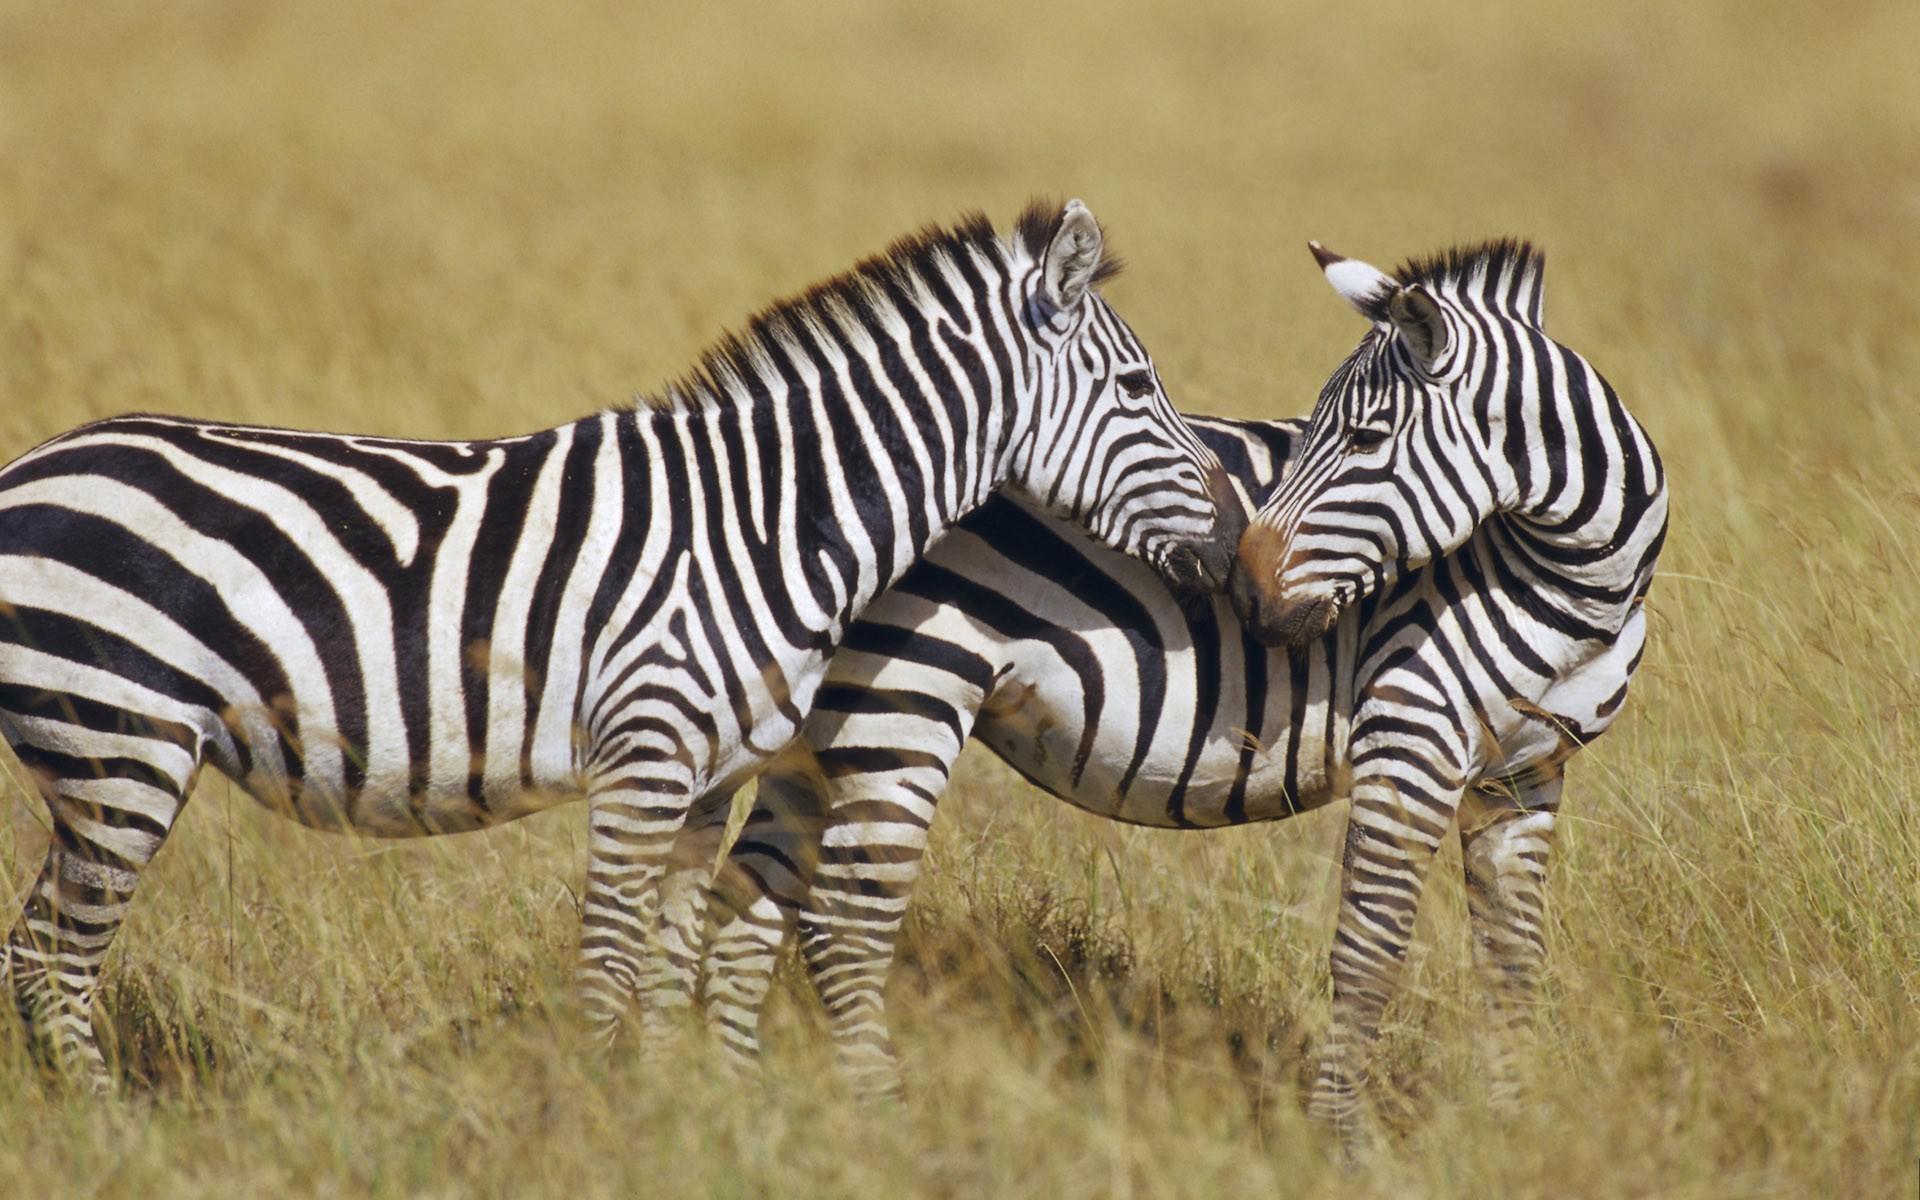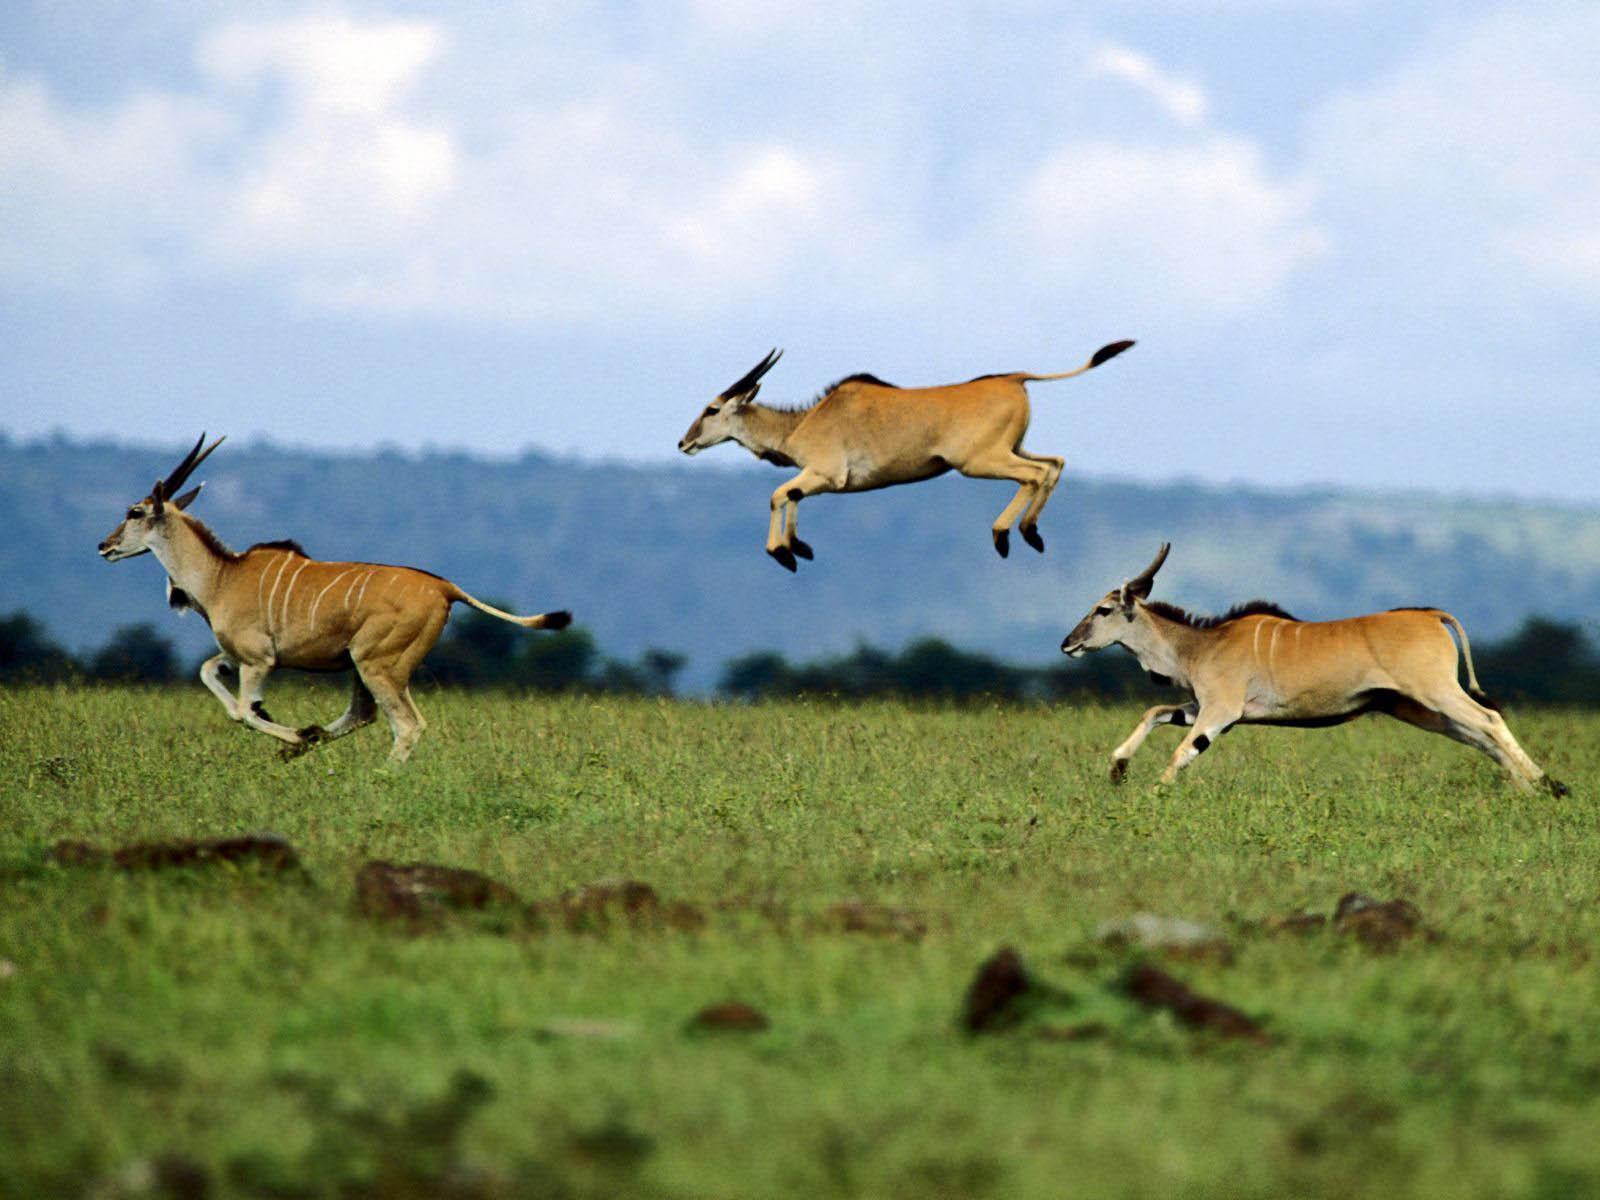The first image is the image on the left, the second image is the image on the right. Given the left and right images, does the statement "Each picture shows exactly two zebras." hold true? Answer yes or no. No. 